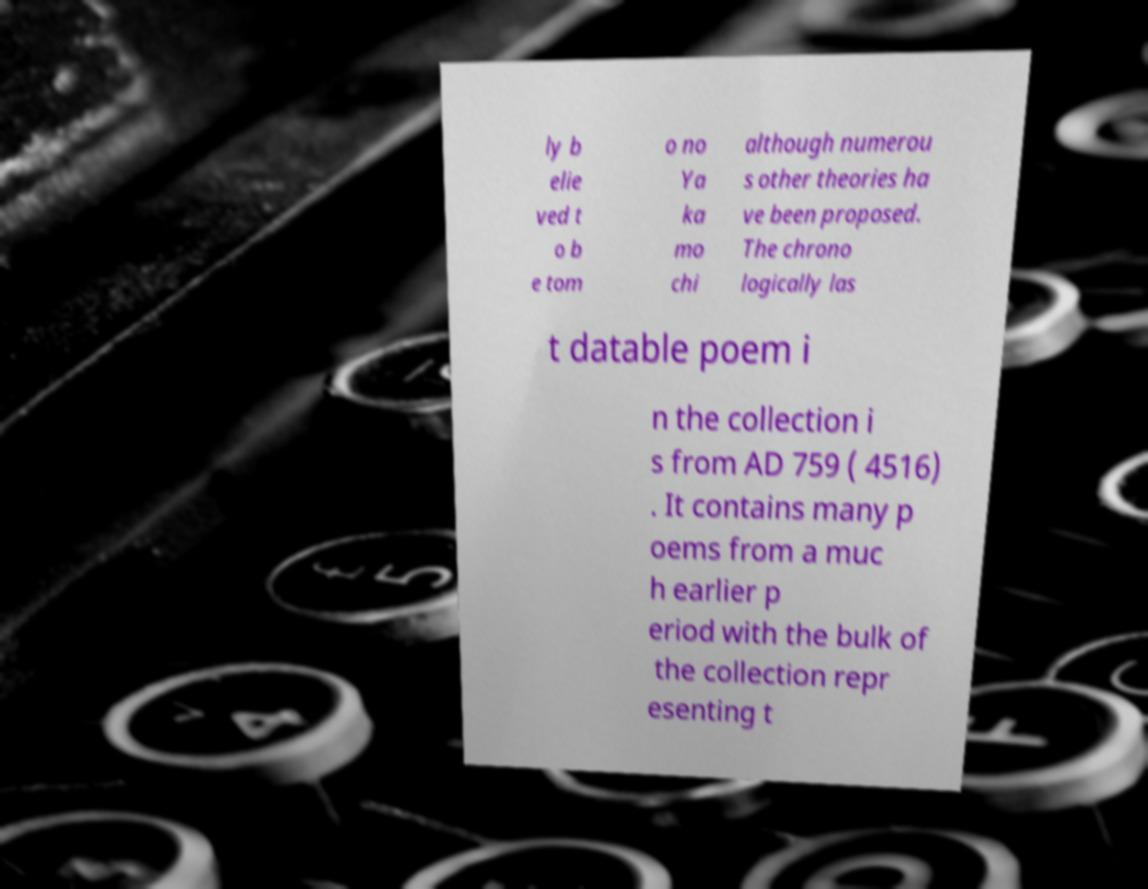Please identify and transcribe the text found in this image. ly b elie ved t o b e tom o no Ya ka mo chi although numerou s other theories ha ve been proposed. The chrono logically las t datable poem i n the collection i s from AD 759 ( 4516) . It contains many p oems from a muc h earlier p eriod with the bulk of the collection repr esenting t 